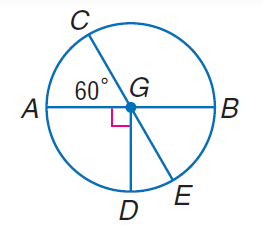How does this diagram relate to the concept of inscribed angles? The concept of inscribed angles is not directly addressed in this diagram since an inscribed angle is one that has its vertex on the circle, and its sides are chords of the circle that intersect at the vertex. However, if a point F were added on the circle such that it connected with points D and E to form triangle DFE, then the angles at D and E would be inscribed angles, and we could talk about their relationship with the intercepted arcs. For example, the measure of an inscribed angle is half the measure of its intercepted arc, demonstrating yet another connection between angles and the arcs they subtend. 